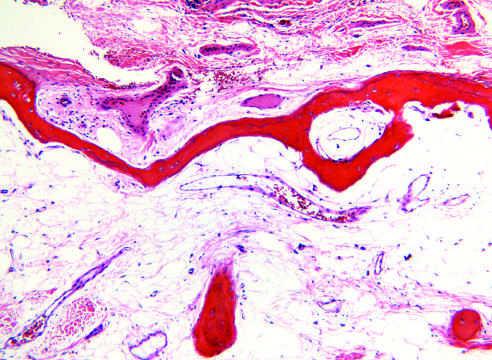re masson trichrome markedly thinned?
Answer the question using a single word or phrase. No 